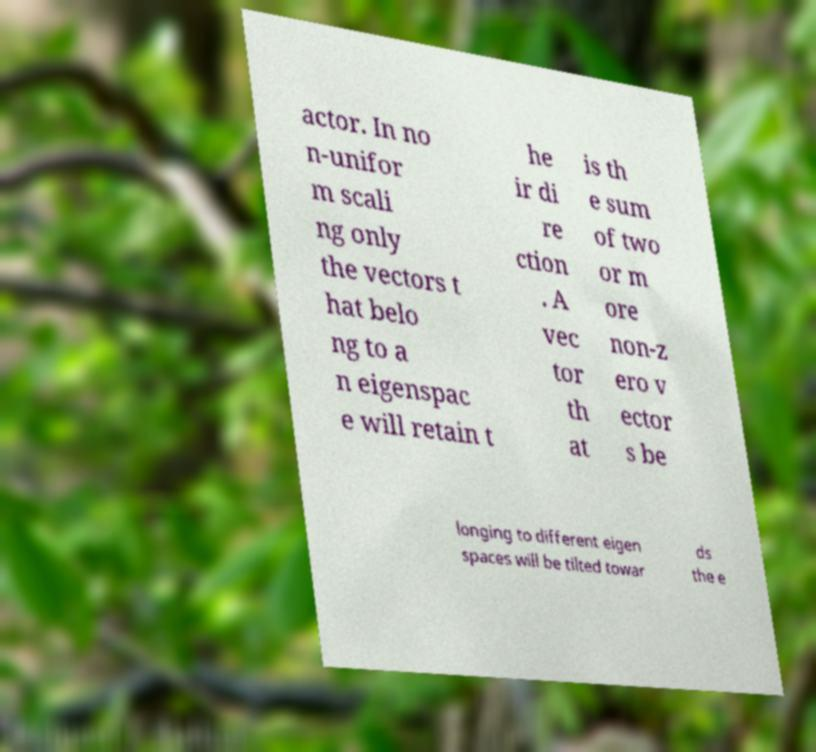Can you accurately transcribe the text from the provided image for me? actor. In no n-unifor m scali ng only the vectors t hat belo ng to a n eigenspac e will retain t he ir di re ction . A vec tor th at is th e sum of two or m ore non-z ero v ector s be longing to different eigen spaces will be tilted towar ds the e 